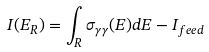Convert formula to latex. <formula><loc_0><loc_0><loc_500><loc_500>I ( E _ { R } ) = \int _ { R } \sigma _ { \gamma \gamma } ( E ) d E - I _ { f e e d }</formula> 